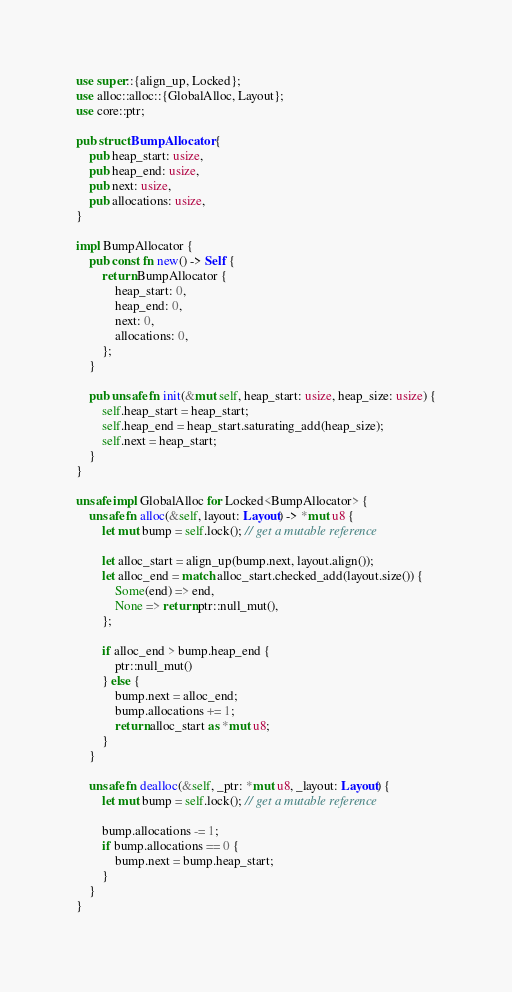Convert code to text. <code><loc_0><loc_0><loc_500><loc_500><_Rust_>use super::{align_up, Locked};
use alloc::alloc::{GlobalAlloc, Layout};
use core::ptr;

pub struct BumpAllocator {
    pub heap_start: usize,
    pub heap_end: usize,
    pub next: usize,
    pub allocations: usize,
}

impl BumpAllocator {
    pub const fn new() -> Self {
        return BumpAllocator {
            heap_start: 0,
            heap_end: 0,
            next: 0,
            allocations: 0,
        };
    }

    pub unsafe fn init(&mut self, heap_start: usize, heap_size: usize) {
        self.heap_start = heap_start;
        self.heap_end = heap_start.saturating_add(heap_size);
        self.next = heap_start;
    }
}

unsafe impl GlobalAlloc for Locked<BumpAllocator> {
    unsafe fn alloc(&self, layout: Layout) -> *mut u8 {
        let mut bump = self.lock(); // get a mutable reference

        let alloc_start = align_up(bump.next, layout.align());
        let alloc_end = match alloc_start.checked_add(layout.size()) {
            Some(end) => end,
            None => return ptr::null_mut(),
        };

        if alloc_end > bump.heap_end {
            ptr::null_mut()
        } else {
            bump.next = alloc_end;
            bump.allocations += 1;
            return alloc_start as *mut u8;
        }
    }

    unsafe fn dealloc(&self, _ptr: *mut u8, _layout: Layout) {
        let mut bump = self.lock(); // get a mutable reference

        bump.allocations -= 1;
        if bump.allocations == 0 {
            bump.next = bump.heap_start;
        }
    }
}
</code> 